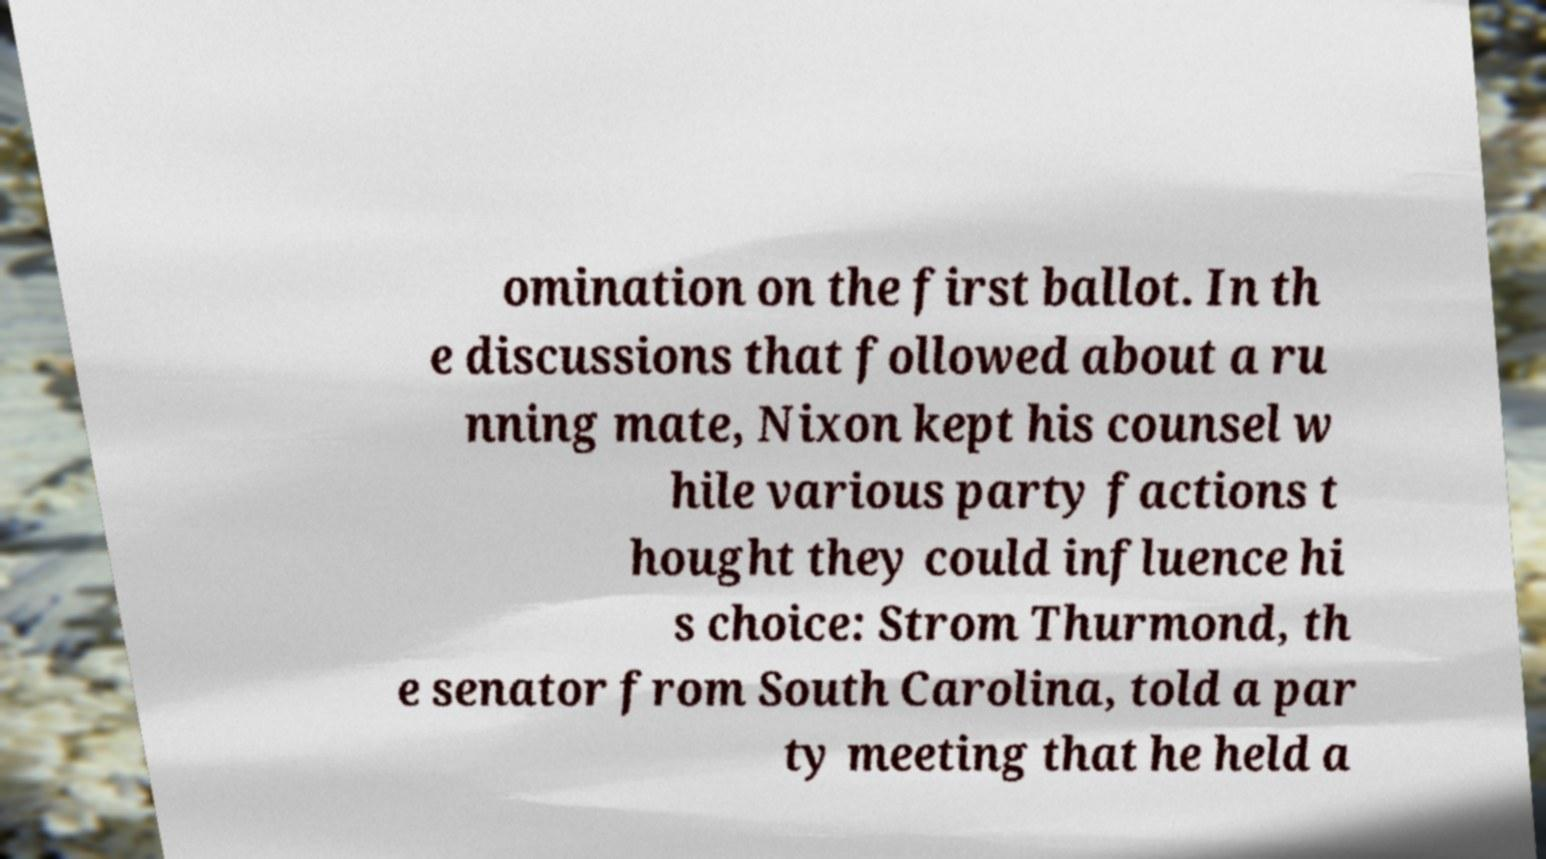Can you read and provide the text displayed in the image?This photo seems to have some interesting text. Can you extract and type it out for me? omination on the first ballot. In th e discussions that followed about a ru nning mate, Nixon kept his counsel w hile various party factions t hought they could influence hi s choice: Strom Thurmond, th e senator from South Carolina, told a par ty meeting that he held a 